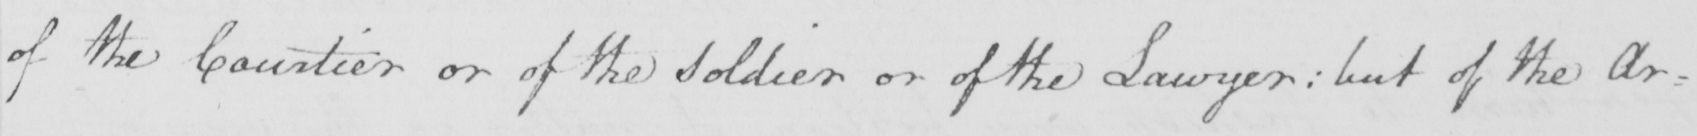What does this handwritten line say? of the Courtier or of the Soldier or of the Lawyer :  but of the Ar= 